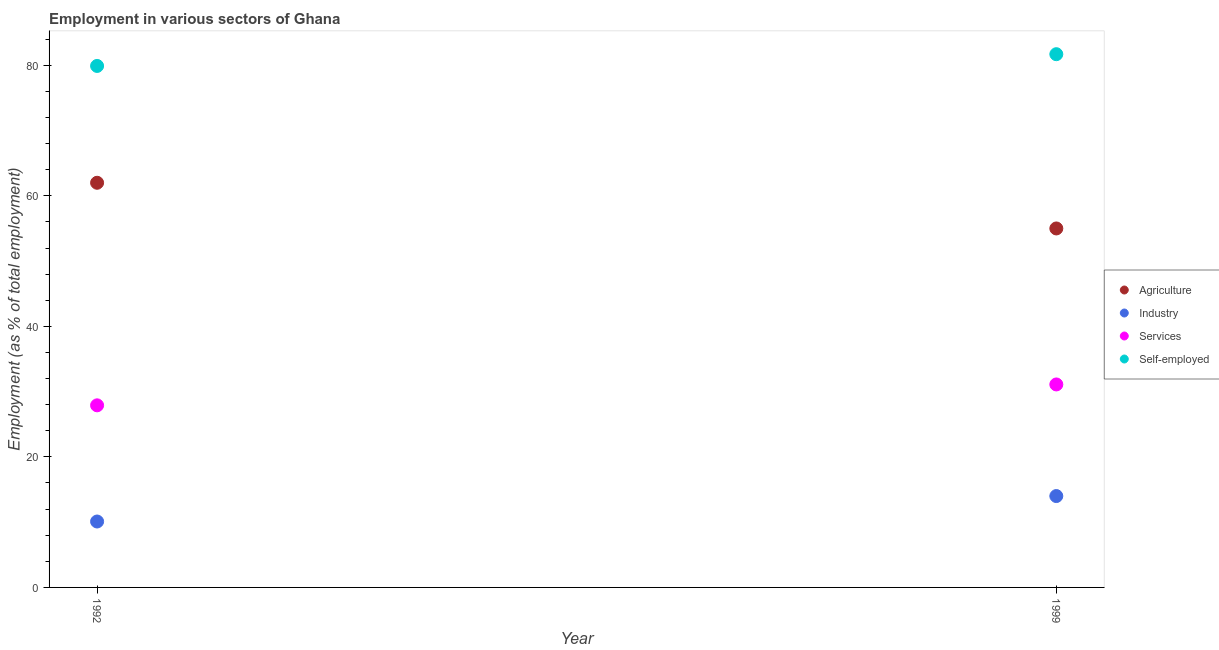How many different coloured dotlines are there?
Keep it short and to the point. 4. Is the number of dotlines equal to the number of legend labels?
Your answer should be very brief. Yes. What is the percentage of workers in agriculture in 1999?
Your answer should be very brief. 55. Across all years, what is the maximum percentage of workers in agriculture?
Ensure brevity in your answer.  62. Across all years, what is the minimum percentage of workers in industry?
Provide a short and direct response. 10.1. What is the total percentage of self employed workers in the graph?
Your answer should be very brief. 161.6. What is the difference between the percentage of workers in industry in 1992 and that in 1999?
Keep it short and to the point. -3.9. What is the difference between the percentage of workers in industry in 1999 and the percentage of self employed workers in 1992?
Offer a very short reply. -65.9. What is the average percentage of self employed workers per year?
Offer a terse response. 80.8. In the year 1992, what is the difference between the percentage of workers in agriculture and percentage of self employed workers?
Keep it short and to the point. -17.9. In how many years, is the percentage of workers in industry greater than 64 %?
Your response must be concise. 0. What is the ratio of the percentage of self employed workers in 1992 to that in 1999?
Your response must be concise. 0.98. Is the percentage of workers in services in 1992 less than that in 1999?
Offer a very short reply. Yes. In how many years, is the percentage of workers in agriculture greater than the average percentage of workers in agriculture taken over all years?
Your answer should be very brief. 1. Is it the case that in every year, the sum of the percentage of workers in agriculture and percentage of workers in industry is greater than the sum of percentage of workers in services and percentage of self employed workers?
Provide a short and direct response. Yes. Does the percentage of workers in services monotonically increase over the years?
Ensure brevity in your answer.  Yes. Is the percentage of workers in industry strictly less than the percentage of workers in agriculture over the years?
Your answer should be compact. Yes. Does the graph contain any zero values?
Offer a terse response. No. Where does the legend appear in the graph?
Ensure brevity in your answer.  Center right. How are the legend labels stacked?
Provide a succinct answer. Vertical. What is the title of the graph?
Offer a very short reply. Employment in various sectors of Ghana. Does "Burnt food" appear as one of the legend labels in the graph?
Your answer should be compact. No. What is the label or title of the X-axis?
Offer a very short reply. Year. What is the label or title of the Y-axis?
Make the answer very short. Employment (as % of total employment). What is the Employment (as % of total employment) in Agriculture in 1992?
Keep it short and to the point. 62. What is the Employment (as % of total employment) in Industry in 1992?
Provide a succinct answer. 10.1. What is the Employment (as % of total employment) in Services in 1992?
Make the answer very short. 27.9. What is the Employment (as % of total employment) in Self-employed in 1992?
Offer a terse response. 79.9. What is the Employment (as % of total employment) of Agriculture in 1999?
Ensure brevity in your answer.  55. What is the Employment (as % of total employment) in Services in 1999?
Provide a succinct answer. 31.1. What is the Employment (as % of total employment) of Self-employed in 1999?
Keep it short and to the point. 81.7. Across all years, what is the maximum Employment (as % of total employment) of Services?
Ensure brevity in your answer.  31.1. Across all years, what is the maximum Employment (as % of total employment) in Self-employed?
Offer a terse response. 81.7. Across all years, what is the minimum Employment (as % of total employment) of Agriculture?
Keep it short and to the point. 55. Across all years, what is the minimum Employment (as % of total employment) of Industry?
Offer a very short reply. 10.1. Across all years, what is the minimum Employment (as % of total employment) in Services?
Offer a terse response. 27.9. Across all years, what is the minimum Employment (as % of total employment) of Self-employed?
Ensure brevity in your answer.  79.9. What is the total Employment (as % of total employment) in Agriculture in the graph?
Your response must be concise. 117. What is the total Employment (as % of total employment) in Industry in the graph?
Give a very brief answer. 24.1. What is the total Employment (as % of total employment) of Self-employed in the graph?
Ensure brevity in your answer.  161.6. What is the difference between the Employment (as % of total employment) of Services in 1992 and that in 1999?
Keep it short and to the point. -3.2. What is the difference between the Employment (as % of total employment) of Self-employed in 1992 and that in 1999?
Make the answer very short. -1.8. What is the difference between the Employment (as % of total employment) in Agriculture in 1992 and the Employment (as % of total employment) in Services in 1999?
Give a very brief answer. 30.9. What is the difference between the Employment (as % of total employment) in Agriculture in 1992 and the Employment (as % of total employment) in Self-employed in 1999?
Your answer should be very brief. -19.7. What is the difference between the Employment (as % of total employment) of Industry in 1992 and the Employment (as % of total employment) of Services in 1999?
Offer a terse response. -21. What is the difference between the Employment (as % of total employment) in Industry in 1992 and the Employment (as % of total employment) in Self-employed in 1999?
Ensure brevity in your answer.  -71.6. What is the difference between the Employment (as % of total employment) in Services in 1992 and the Employment (as % of total employment) in Self-employed in 1999?
Ensure brevity in your answer.  -53.8. What is the average Employment (as % of total employment) of Agriculture per year?
Make the answer very short. 58.5. What is the average Employment (as % of total employment) in Industry per year?
Keep it short and to the point. 12.05. What is the average Employment (as % of total employment) of Services per year?
Provide a short and direct response. 29.5. What is the average Employment (as % of total employment) of Self-employed per year?
Your answer should be very brief. 80.8. In the year 1992, what is the difference between the Employment (as % of total employment) in Agriculture and Employment (as % of total employment) in Industry?
Your answer should be very brief. 51.9. In the year 1992, what is the difference between the Employment (as % of total employment) in Agriculture and Employment (as % of total employment) in Services?
Give a very brief answer. 34.1. In the year 1992, what is the difference between the Employment (as % of total employment) in Agriculture and Employment (as % of total employment) in Self-employed?
Provide a succinct answer. -17.9. In the year 1992, what is the difference between the Employment (as % of total employment) in Industry and Employment (as % of total employment) in Services?
Provide a succinct answer. -17.8. In the year 1992, what is the difference between the Employment (as % of total employment) of Industry and Employment (as % of total employment) of Self-employed?
Offer a very short reply. -69.8. In the year 1992, what is the difference between the Employment (as % of total employment) of Services and Employment (as % of total employment) of Self-employed?
Keep it short and to the point. -52. In the year 1999, what is the difference between the Employment (as % of total employment) in Agriculture and Employment (as % of total employment) in Services?
Keep it short and to the point. 23.9. In the year 1999, what is the difference between the Employment (as % of total employment) in Agriculture and Employment (as % of total employment) in Self-employed?
Give a very brief answer. -26.7. In the year 1999, what is the difference between the Employment (as % of total employment) in Industry and Employment (as % of total employment) in Services?
Your answer should be compact. -17.1. In the year 1999, what is the difference between the Employment (as % of total employment) in Industry and Employment (as % of total employment) in Self-employed?
Make the answer very short. -67.7. In the year 1999, what is the difference between the Employment (as % of total employment) of Services and Employment (as % of total employment) of Self-employed?
Keep it short and to the point. -50.6. What is the ratio of the Employment (as % of total employment) in Agriculture in 1992 to that in 1999?
Ensure brevity in your answer.  1.13. What is the ratio of the Employment (as % of total employment) of Industry in 1992 to that in 1999?
Offer a terse response. 0.72. What is the ratio of the Employment (as % of total employment) in Services in 1992 to that in 1999?
Offer a very short reply. 0.9. What is the difference between the highest and the second highest Employment (as % of total employment) in Agriculture?
Your answer should be very brief. 7. What is the difference between the highest and the second highest Employment (as % of total employment) of Services?
Give a very brief answer. 3.2. What is the difference between the highest and the lowest Employment (as % of total employment) of Agriculture?
Keep it short and to the point. 7. What is the difference between the highest and the lowest Employment (as % of total employment) of Industry?
Provide a succinct answer. 3.9. What is the difference between the highest and the lowest Employment (as % of total employment) in Services?
Make the answer very short. 3.2. 